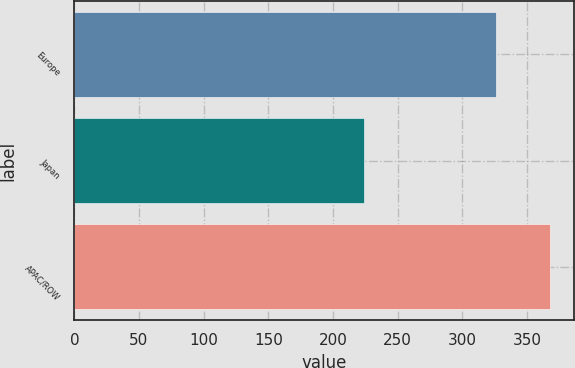Convert chart to OTSL. <chart><loc_0><loc_0><loc_500><loc_500><bar_chart><fcel>Europe<fcel>Japan<fcel>APAC/ROW<nl><fcel>326.1<fcel>224.1<fcel>367.9<nl></chart> 